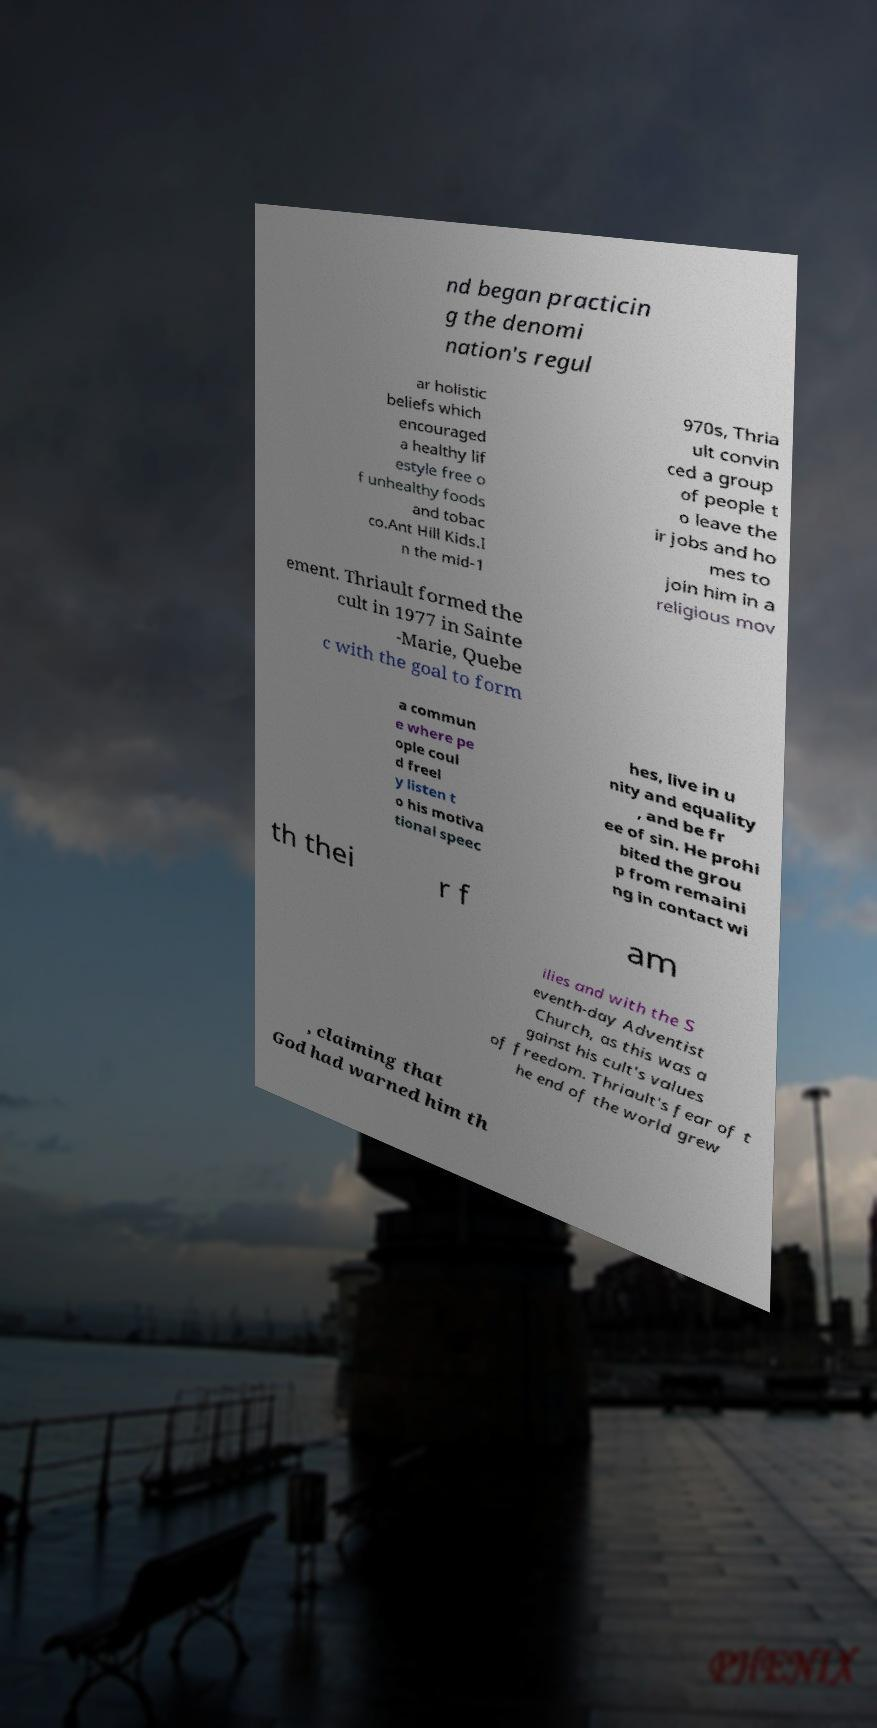For documentation purposes, I need the text within this image transcribed. Could you provide that? nd began practicin g the denomi nation's regul ar holistic beliefs which encouraged a healthy lif estyle free o f unhealthy foods and tobac co.Ant Hill Kids.I n the mid-1 970s, Thria ult convin ced a group of people t o leave the ir jobs and ho mes to join him in a religious mov ement. Thriault formed the cult in 1977 in Sainte -Marie, Quebe c with the goal to form a commun e where pe ople coul d freel y listen t o his motiva tional speec hes, live in u nity and equality , and be fr ee of sin. He prohi bited the grou p from remaini ng in contact wi th thei r f am ilies and with the S eventh-day Adventist Church, as this was a gainst his cult's values of freedom. Thriault's fear of t he end of the world grew , claiming that God had warned him th 